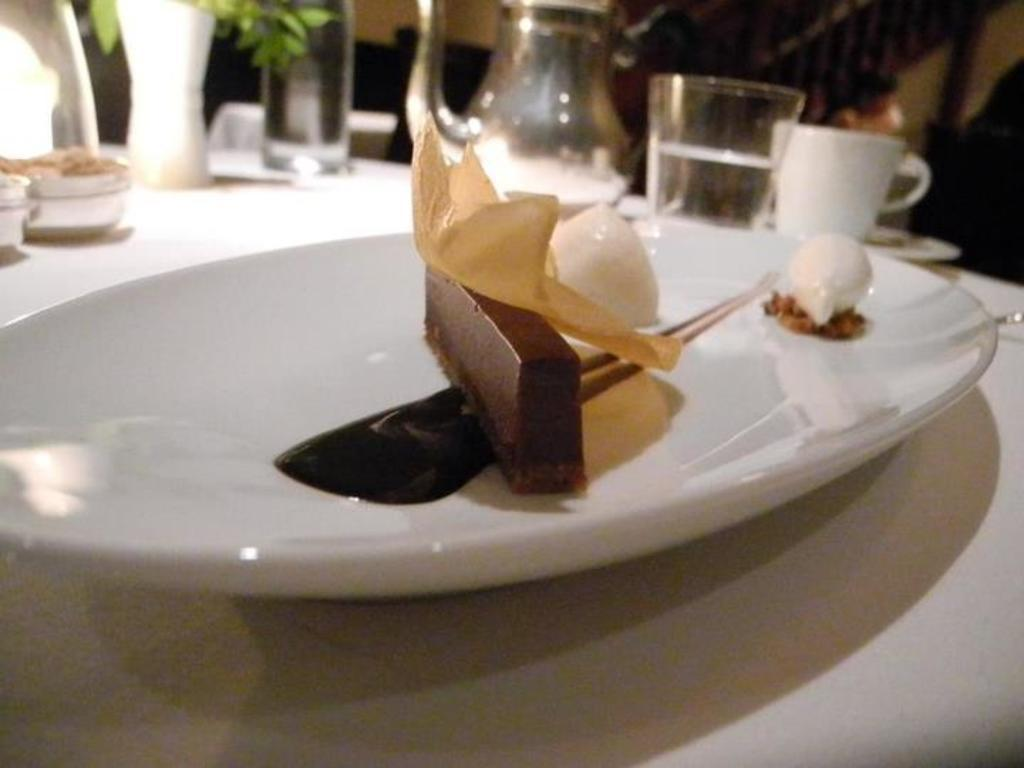What is the main subject of the image? The image is a zoom-in of a food item. How is the food item presented in the image? The food item is placed on a white color plate. What other objects can be seen in the image? There is a jug, a glass, a cup, and a flower vase in the image. How far away is the sister from the food item in the image? There is no sister present in the image, so it is not possible to determine the distance between her and the food item. 